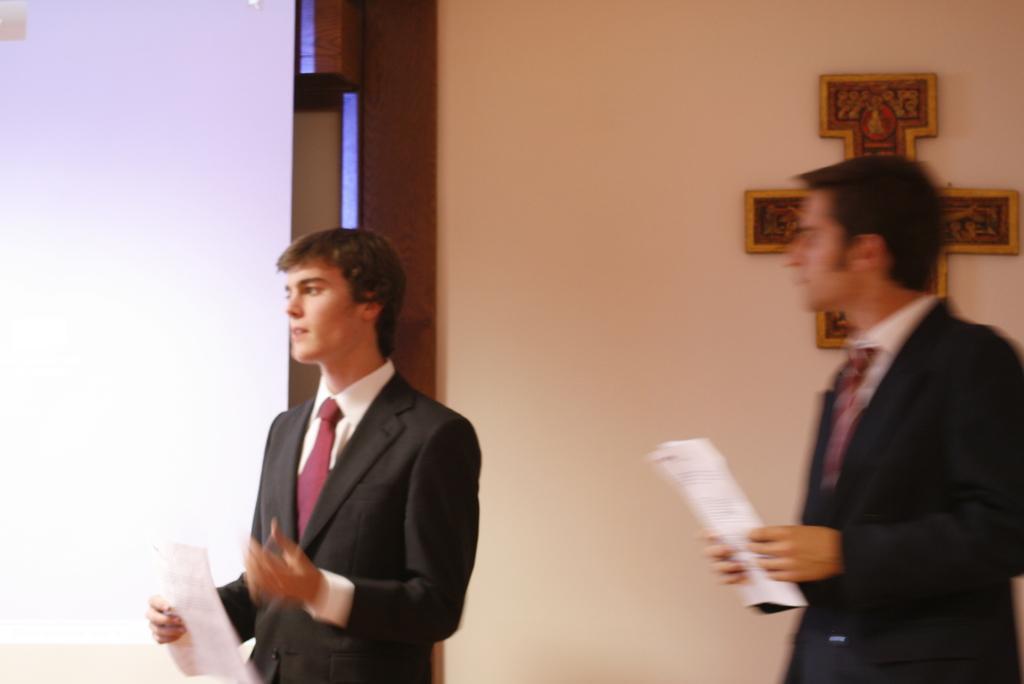Describe this image in one or two sentences. In this image, we can see two persons standing and they are holding papers in the hands, in the background there is a wall. 